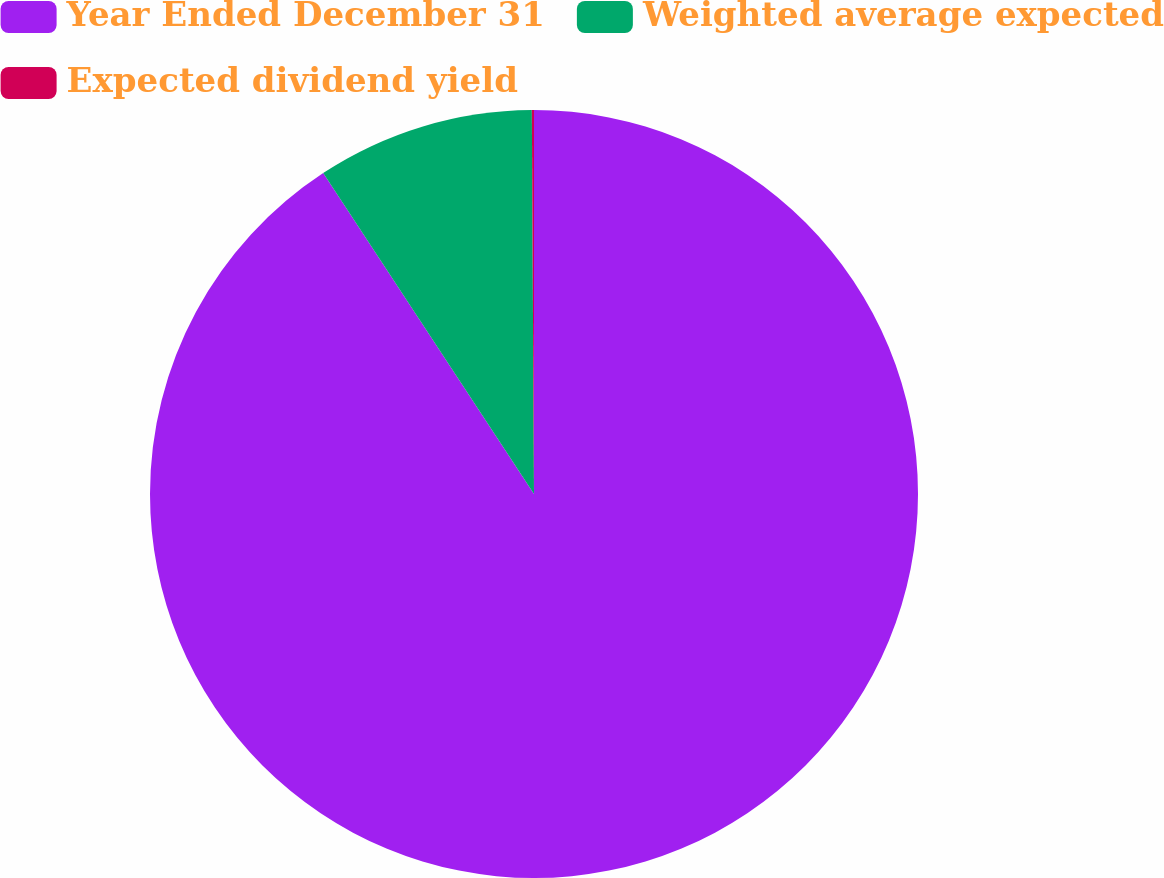Convert chart to OTSL. <chart><loc_0><loc_0><loc_500><loc_500><pie_chart><fcel>Year Ended December 31<fcel>Weighted average expected<fcel>Expected dividend yield<nl><fcel>90.75%<fcel>9.16%<fcel>0.09%<nl></chart> 